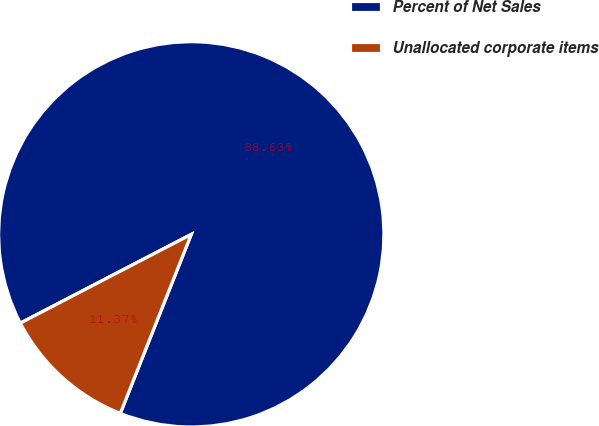Convert chart. <chart><loc_0><loc_0><loc_500><loc_500><pie_chart><fcel>Percent of Net Sales<fcel>Unallocated corporate items<nl><fcel>88.63%<fcel>11.37%<nl></chart> 